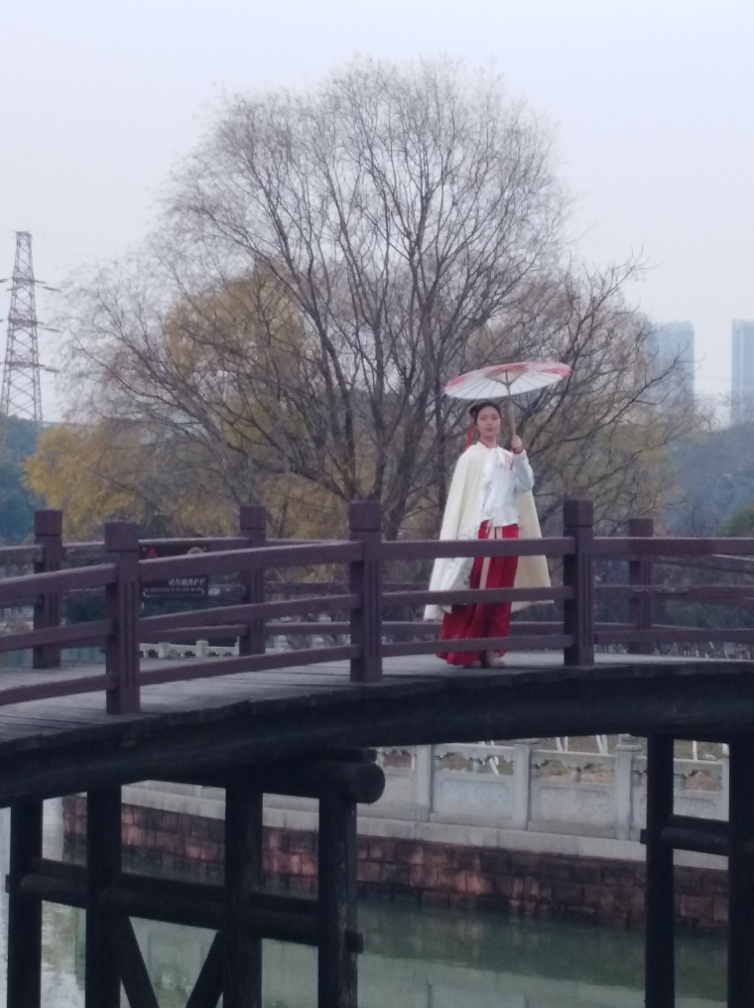Are the texture details of the wooden bridge rich?
A. No
B. Yes
Answer with the option's letter from the given choices directly.
 B. 